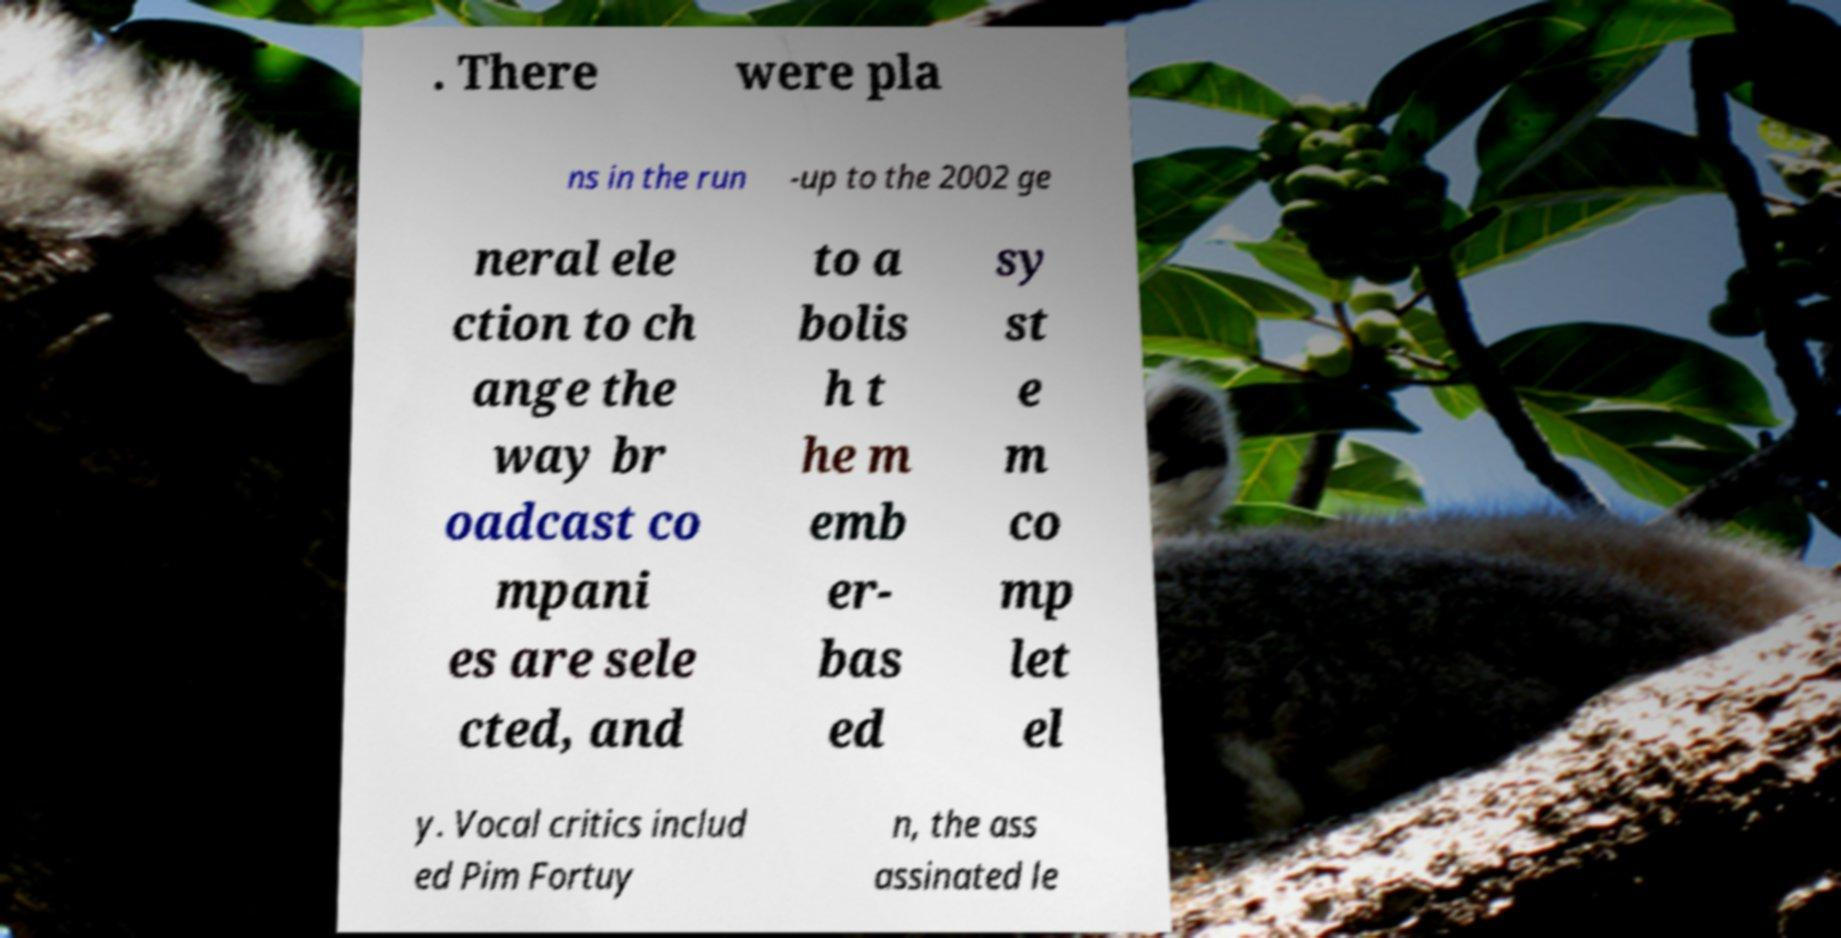There's text embedded in this image that I need extracted. Can you transcribe it verbatim? . There were pla ns in the run -up to the 2002 ge neral ele ction to ch ange the way br oadcast co mpani es are sele cted, and to a bolis h t he m emb er- bas ed sy st e m co mp let el y. Vocal critics includ ed Pim Fortuy n, the ass assinated le 